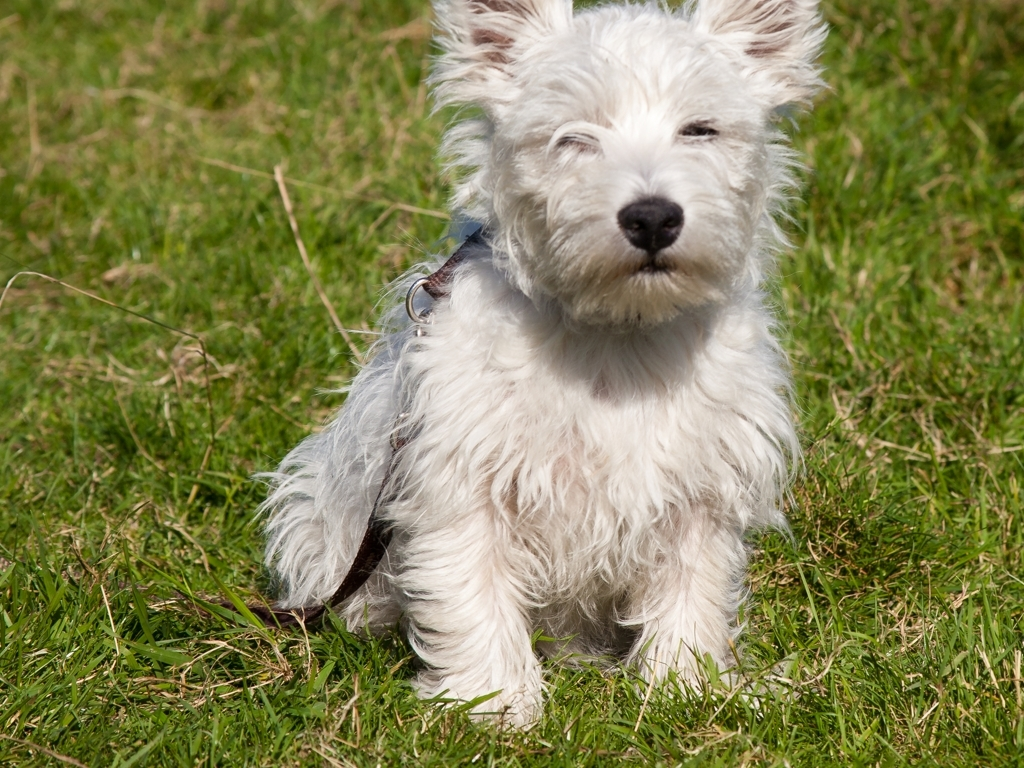Can you tell me what breed of dog this might be? This dog appears to be a West Highland White Terrier, commonly known as a Westie. This breed is known for its distinctive white coat, pointed ears, and bright, button eyes, which are all features evident in this image. What kind of environment do they thrive in? Westies are versatile and can adapt to various living conditions. They do well in both country and city settings, appreciating regular exercise and playtime. As a sturdy and active breed, they enjoy having space to explore but can also adapt to apartment living if provided with enough physical activity. 